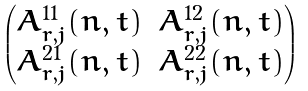<formula> <loc_0><loc_0><loc_500><loc_500>\begin{pmatrix} A _ { r , j } ^ { 1 1 } ( n , t ) & A _ { r , j } ^ { 1 2 } ( n , t ) \\ A _ { r , j } ^ { 2 1 } ( n , t ) & A _ { r , j } ^ { 2 2 } ( n , t ) \end{pmatrix}</formula> 